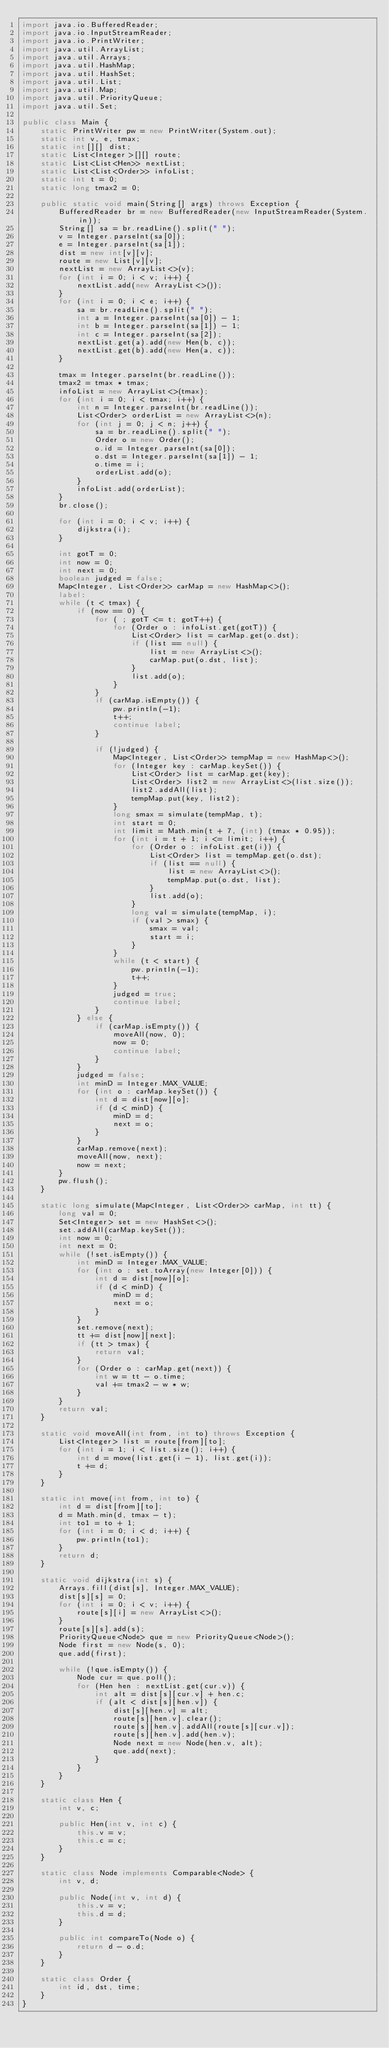<code> <loc_0><loc_0><loc_500><loc_500><_Java_>import java.io.BufferedReader;
import java.io.InputStreamReader;
import java.io.PrintWriter;
import java.util.ArrayList;
import java.util.Arrays;
import java.util.HashMap;
import java.util.HashSet;
import java.util.List;
import java.util.Map;
import java.util.PriorityQueue;
import java.util.Set;

public class Main {
	static PrintWriter pw = new PrintWriter(System.out);
	static int v, e, tmax;
	static int[][] dist;
	static List<Integer>[][] route;
	static List<List<Hen>> nextList;
	static List<List<Order>> infoList;
	static int t = 0;
	static long tmax2 = 0;

	public static void main(String[] args) throws Exception {
		BufferedReader br = new BufferedReader(new InputStreamReader(System.in));
		String[] sa = br.readLine().split(" ");
		v = Integer.parseInt(sa[0]);
		e = Integer.parseInt(sa[1]);
		dist = new int[v][v];
		route = new List[v][v];
		nextList = new ArrayList<>(v);
		for (int i = 0; i < v; i++) {
			nextList.add(new ArrayList<>());
		}
		for (int i = 0; i < e; i++) {
			sa = br.readLine().split(" ");
			int a = Integer.parseInt(sa[0]) - 1;
			int b = Integer.parseInt(sa[1]) - 1;
			int c = Integer.parseInt(sa[2]);
			nextList.get(a).add(new Hen(b, c));
			nextList.get(b).add(new Hen(a, c));
		}

		tmax = Integer.parseInt(br.readLine());
		tmax2 = tmax * tmax;
		infoList = new ArrayList<>(tmax);
		for (int i = 0; i < tmax; i++) {
			int n = Integer.parseInt(br.readLine());
			List<Order> orderList = new ArrayList<>(n);
			for (int j = 0; j < n; j++) {
				sa = br.readLine().split(" ");
				Order o = new Order();
				o.id = Integer.parseInt(sa[0]);
				o.dst = Integer.parseInt(sa[1]) - 1;
				o.time = i;
				orderList.add(o);
			}
			infoList.add(orderList);
		}
		br.close();

		for (int i = 0; i < v; i++) {
			dijkstra(i);
		}

		int gotT = 0;
		int now = 0;
		int next = 0;
		boolean judged = false;
		Map<Integer, List<Order>> carMap = new HashMap<>();
		label:
		while (t < tmax) {
			if (now == 0) {
				for ( ; gotT <= t; gotT++) {
					for (Order o : infoList.get(gotT)) {
						List<Order> list = carMap.get(o.dst);
						if (list == null) {
							list = new ArrayList<>();
							carMap.put(o.dst, list);
						}
						list.add(o);
					}
				}
				if (carMap.isEmpty()) {
					pw.println(-1);
					t++;
					continue label;
				}

				if (!judged) {
					Map<Integer, List<Order>> tempMap = new HashMap<>();
					for (Integer key : carMap.keySet()) {
						List<Order> list = carMap.get(key);
						List<Order> list2 = new ArrayList<>(list.size());
						list2.addAll(list);
						tempMap.put(key, list2);
					}
					long smax = simulate(tempMap, t);
					int start = 0;
					int limit = Math.min(t + 7, (int) (tmax * 0.95));
					for (int i = t + 1; i <= limit; i++) {
						for (Order o : infoList.get(i)) {
							List<Order> list = tempMap.get(o.dst);
							if (list == null) {
								list = new ArrayList<>();
								tempMap.put(o.dst, list);
							}
							list.add(o);
						}
						long val = simulate(tempMap, i);
						if (val > smax) {
							smax = val;
							start = i;
						}
					}
					while (t < start) {
						pw.println(-1);
						t++;
					}
					judged = true;
					continue label;
				}
			} else {
				if (carMap.isEmpty()) {
					moveAll(now, 0);
					now = 0;
					continue label;
				}
			}
			judged = false;
			int minD = Integer.MAX_VALUE;
			for (int o : carMap.keySet()) {
				int d = dist[now][o];
				if (d < minD) {
					minD = d;
					next = o;
				}
			}
			carMap.remove(next);
			moveAll(now, next);
			now = next;
		}
		pw.flush();
	}

	static long simulate(Map<Integer, List<Order>> carMap, int tt) {
		long val = 0;
		Set<Integer> set = new HashSet<>();
		set.addAll(carMap.keySet());
		int now = 0;
		int next = 0;
		while (!set.isEmpty()) {
			int minD = Integer.MAX_VALUE;
			for (int o : set.toArray(new Integer[0])) {
				int d = dist[now][o];
				if (d < minD) {
					minD = d;
					next = o;
				}
			}
			set.remove(next);
			tt += dist[now][next];
			if (tt > tmax) {
				return val;
			}
			for (Order o : carMap.get(next)) {
				int w = tt - o.time;
				val += tmax2 - w * w;
			}
		}
		return val;
	}

	static void moveAll(int from, int to) throws Exception {
		List<Integer> list = route[from][to];
		for (int i = 1; i < list.size(); i++) {
			int d = move(list.get(i - 1), list.get(i));
			t += d;
		}
	}

	static int move(int from, int to) {
		int d = dist[from][to];
		d = Math.min(d, tmax - t);
		int to1 = to + 1;
		for (int i = 0; i < d; i++) {
			pw.println(to1);
		}
		return d;
	}

	static void dijkstra(int s) {
		Arrays.fill(dist[s], Integer.MAX_VALUE);
		dist[s][s] = 0;
		for (int i = 0; i < v; i++) {
			route[s][i] = new ArrayList<>();
		}
		route[s][s].add(s);
		PriorityQueue<Node> que = new PriorityQueue<Node>();
		Node first = new Node(s, 0);
		que.add(first);

		while (!que.isEmpty()) {
			Node cur = que.poll();
			for (Hen hen : nextList.get(cur.v)) {
				int alt = dist[s][cur.v] + hen.c;
				if (alt < dist[s][hen.v]) {
					dist[s][hen.v] = alt;
					route[s][hen.v].clear();
					route[s][hen.v].addAll(route[s][cur.v]);
					route[s][hen.v].add(hen.v);
					Node next = new Node(hen.v, alt);
					que.add(next);
				}
			}
		}
	}

	static class Hen {
		int v, c;

		public Hen(int v, int c) {
			this.v = v;
			this.c = c;
		}
	}

	static class Node implements Comparable<Node> {
		int v, d;

		public Node(int v, int d) {
			this.v = v;
			this.d = d;
		}

		public int compareTo(Node o) {
			return d - o.d;
		}
	}

	static class Order {
		int id, dst, time;
	}
}
</code> 